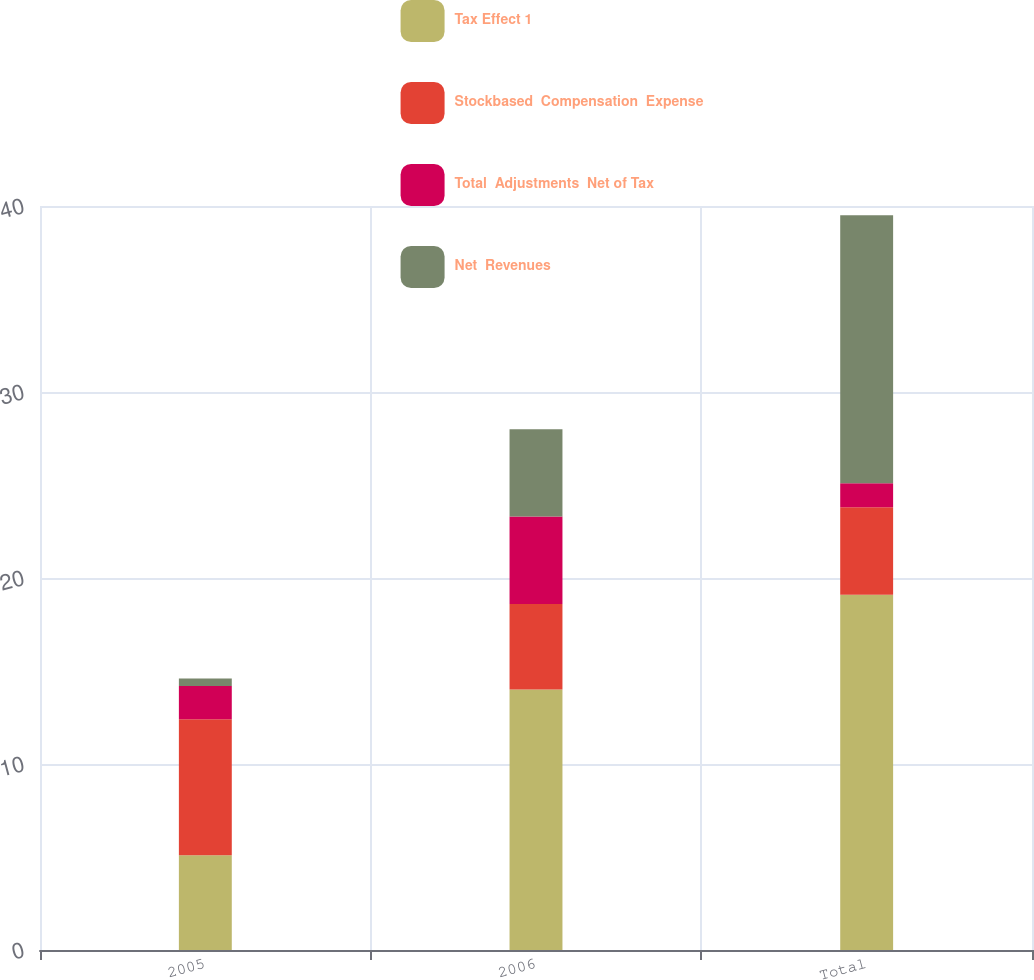Convert chart to OTSL. <chart><loc_0><loc_0><loc_500><loc_500><stacked_bar_chart><ecel><fcel>2005<fcel>2006<fcel>Total<nl><fcel>Tax Effect 1<fcel>5.1<fcel>14<fcel>19.1<nl><fcel>Stockbased  Compensation  Expense<fcel>7.3<fcel>4.6<fcel>4.7<nl><fcel>Total  Adjustments  Net of Tax<fcel>1.8<fcel>4.7<fcel>1.3<nl><fcel>Net  Revenues<fcel>0.4<fcel>4.7<fcel>14.4<nl></chart> 